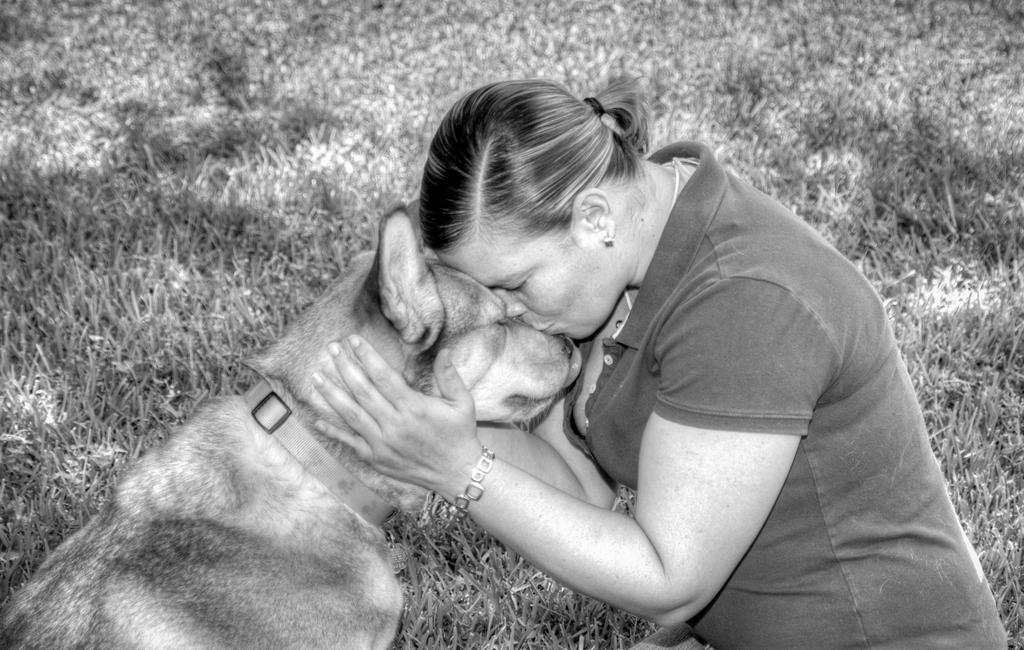Could you give a brief overview of what you see in this image? In this image I can see a woman kissing a dog. In the background I can see the grass. This is a black and white image. She's wearing a watch to her left hand. 